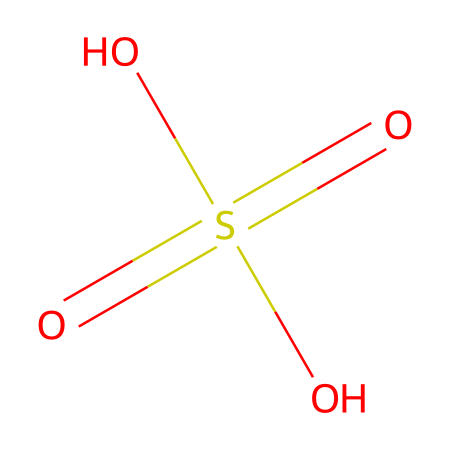What is the main functional group present in this chemical? The chemical has a sulfonic acid group, indicated by the sulfonyl (S(=O)(O)) part of the structure.
Answer: sulfonic acid How many oxygen atoms are in the structure? Counting from the SMILES representation, there are four oxygen atoms present in the molecule.
Answer: four What is the oxidation state of sulfur in this chemical? In this structure, sulfur is bonded to four oxygen atoms, which indicates its oxidation state is +6.
Answer: +6 Can this acid be classified as a strong acid? Sulfuric acid is widely known to be a strong acid due to its complete dissociation in water.
Answer: yes What is the impact of this acid on fossil preservation? Sulfuric acid can lead to mineral dissolution and alteration, affecting fossil integrity during burial.
Answer: mineral alteration What is the chemical’s molecular formula? The molecular formula can be deduced from the SMILES, which indicates that the compound consists of H2O4S.
Answer: H2O4S What kind of bond is predominantly formed between sulfur and oxygen in this acid? The structure exhibits covalent bonding between the sulfur and oxygen atoms, which is characteristic of acids like sulfuric acid.
Answer: covalent 